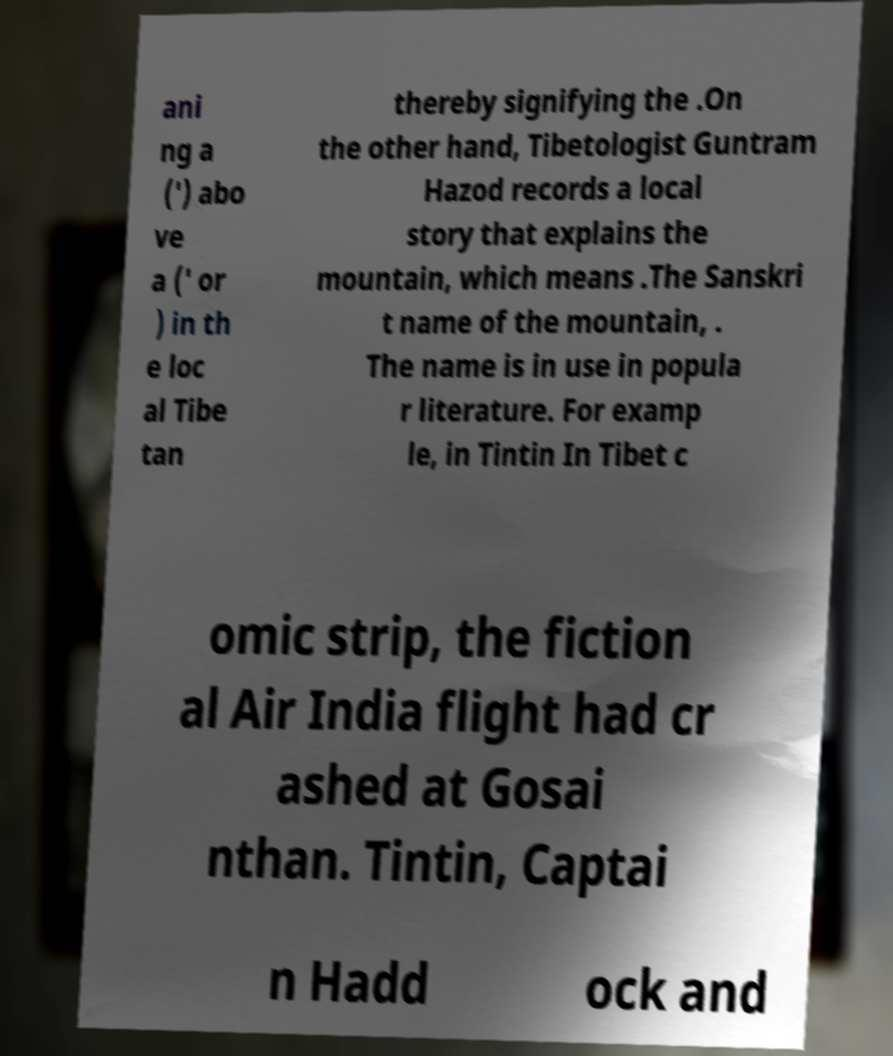Could you assist in decoding the text presented in this image and type it out clearly? ani ng a (') abo ve a (' or ) in th e loc al Tibe tan thereby signifying the .On the other hand, Tibetologist Guntram Hazod records a local story that explains the mountain, which means .The Sanskri t name of the mountain, . The name is in use in popula r literature. For examp le, in Tintin In Tibet c omic strip, the fiction al Air India flight had cr ashed at Gosai nthan. Tintin, Captai n Hadd ock and 